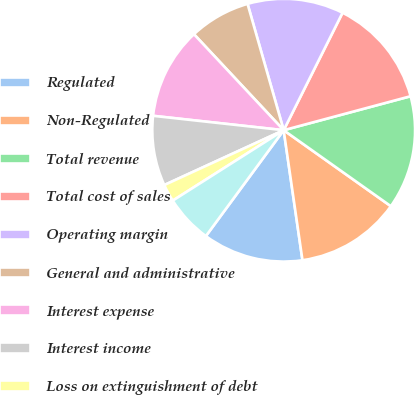Convert chart to OTSL. <chart><loc_0><loc_0><loc_500><loc_500><pie_chart><fcel>Regulated<fcel>Non-Regulated<fcel>Total revenue<fcel>Total cost of sales<fcel>Operating margin<fcel>General and administrative<fcel>Interest expense<fcel>Interest income<fcel>Loss on extinguishment of debt<fcel>Other expense<nl><fcel>12.37%<fcel>12.9%<fcel>13.98%<fcel>13.44%<fcel>11.83%<fcel>7.53%<fcel>11.29%<fcel>8.6%<fcel>2.15%<fcel>5.91%<nl></chart> 